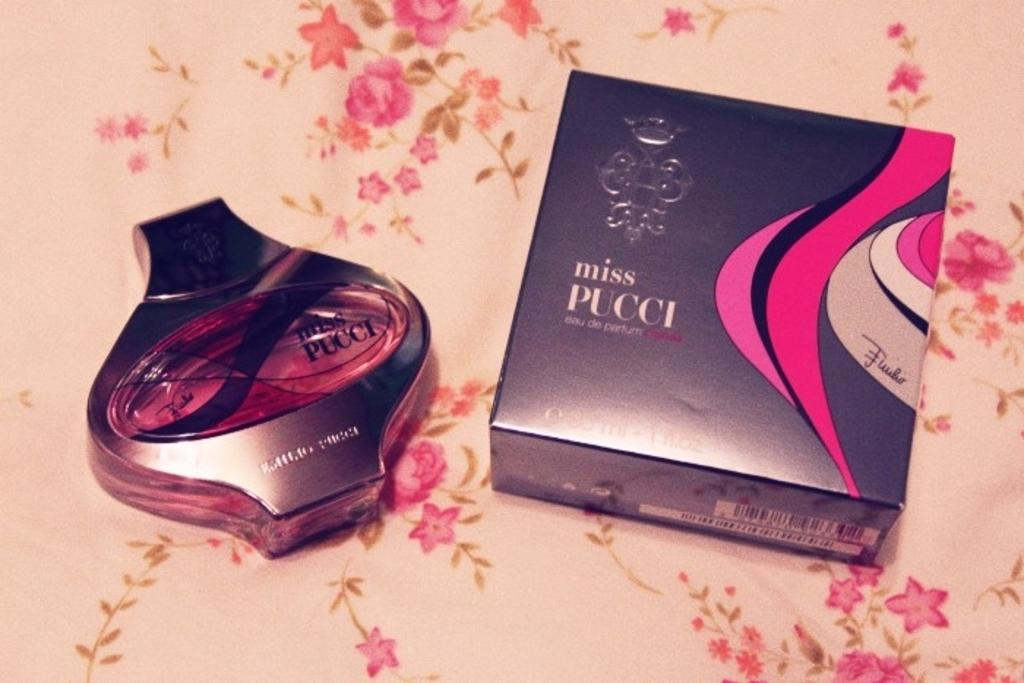<image>
Give a short and clear explanation of the subsequent image. A bottle of a perfume, miss Pucci, is next to its box on a floral table. 